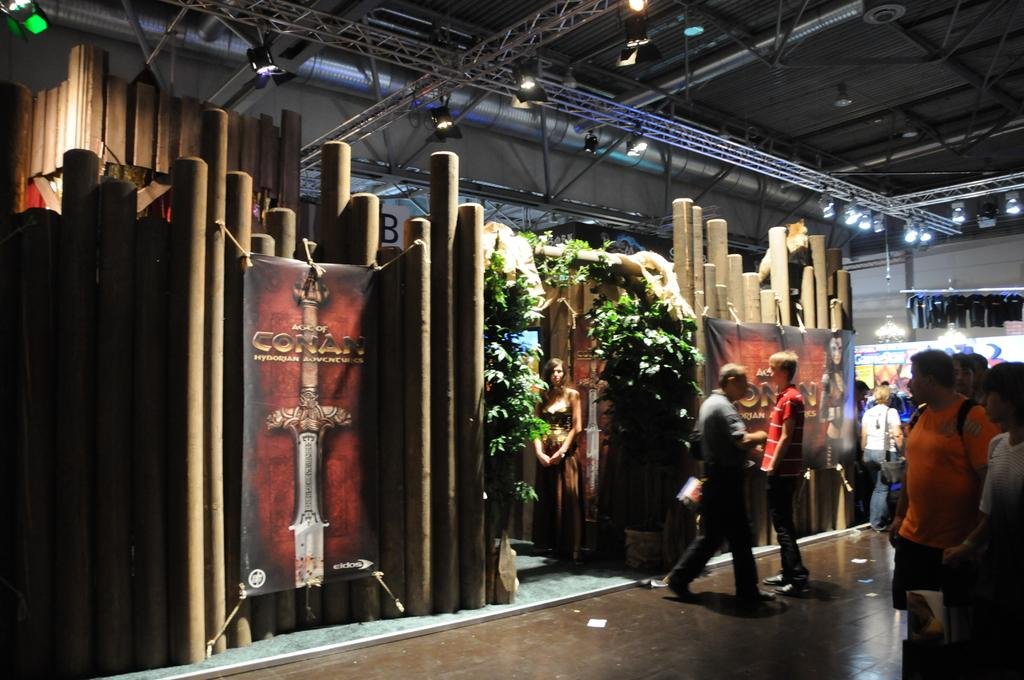What are the people in the image doing? There is a group of people on the floor in the image. What can be seen hanging in the image? There are banners in the image. What type of vegetation is present in the image? There are plants in the image. What can be seen providing illumination in the image? There are lights in the image. What type of structural elements are present in the image? There are rods in the image. What type of architectural feature is visible in the image? There is a roof in the image. What is visible in the background of the image? There is a wall visible in the background of the image, along with some unspecified objects. How many bikes are parked on the island in the image? There are no bikes or islands present in the image. What type of creature is seen playing with the part in the image? There is no creature or part present in the image. 